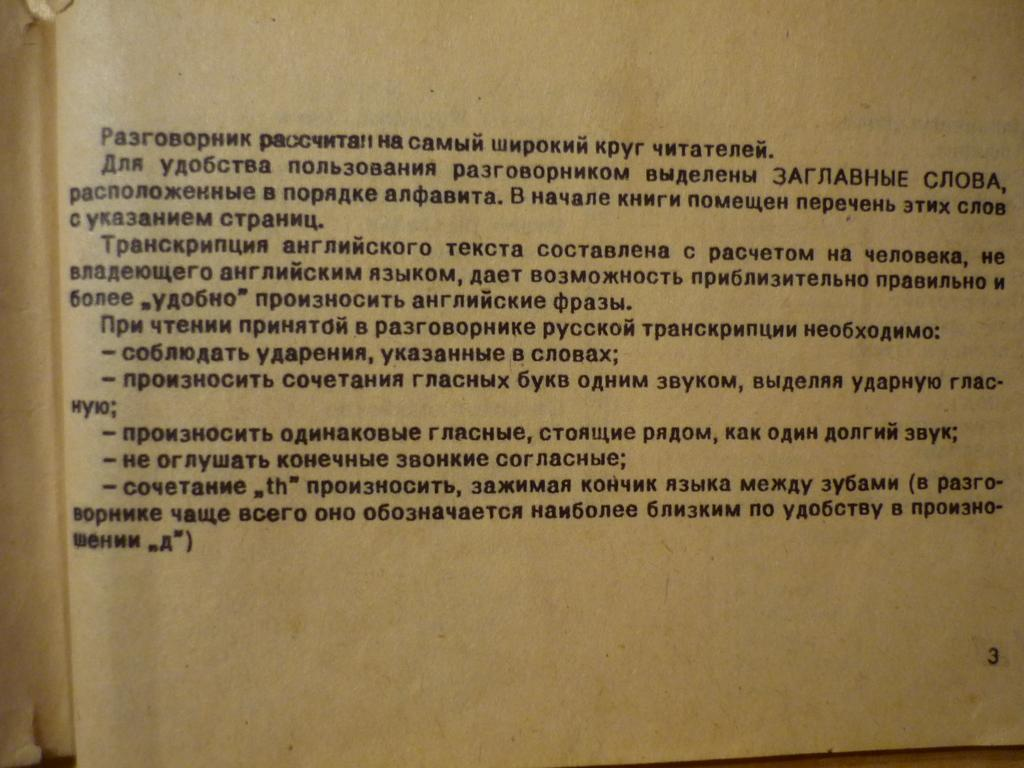<image>
Create a compact narrative representing the image presented. The book shown is opened up to page number 3. 